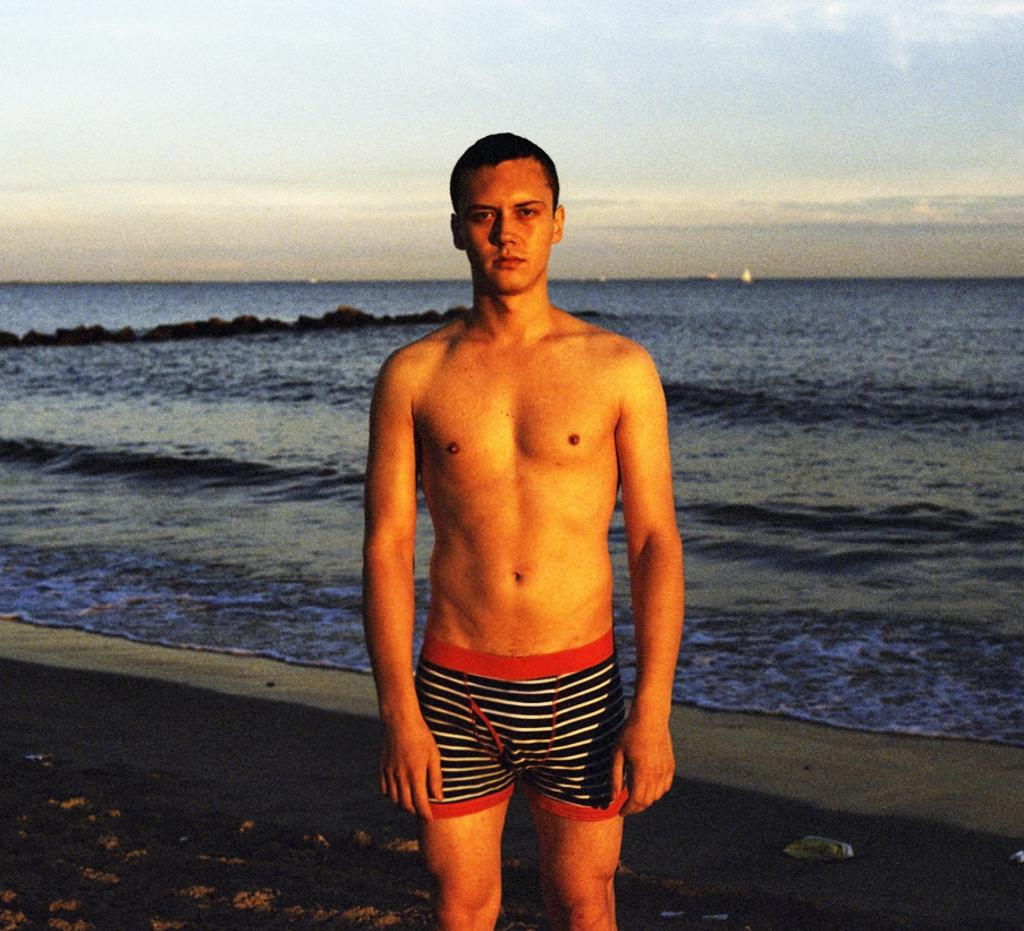Who is the main subject in the image? There is a boy in the image. Where is the boy positioned in the image? The boy is standing in the center of the image. What can be seen in the background of the image? There is water visible in the background of the image. What type of cloth is the boy using to move across the sidewalk in the image? There is no sidewalk or cloth present in the image; the boy is standing in the center of the image with water visible in the background. 